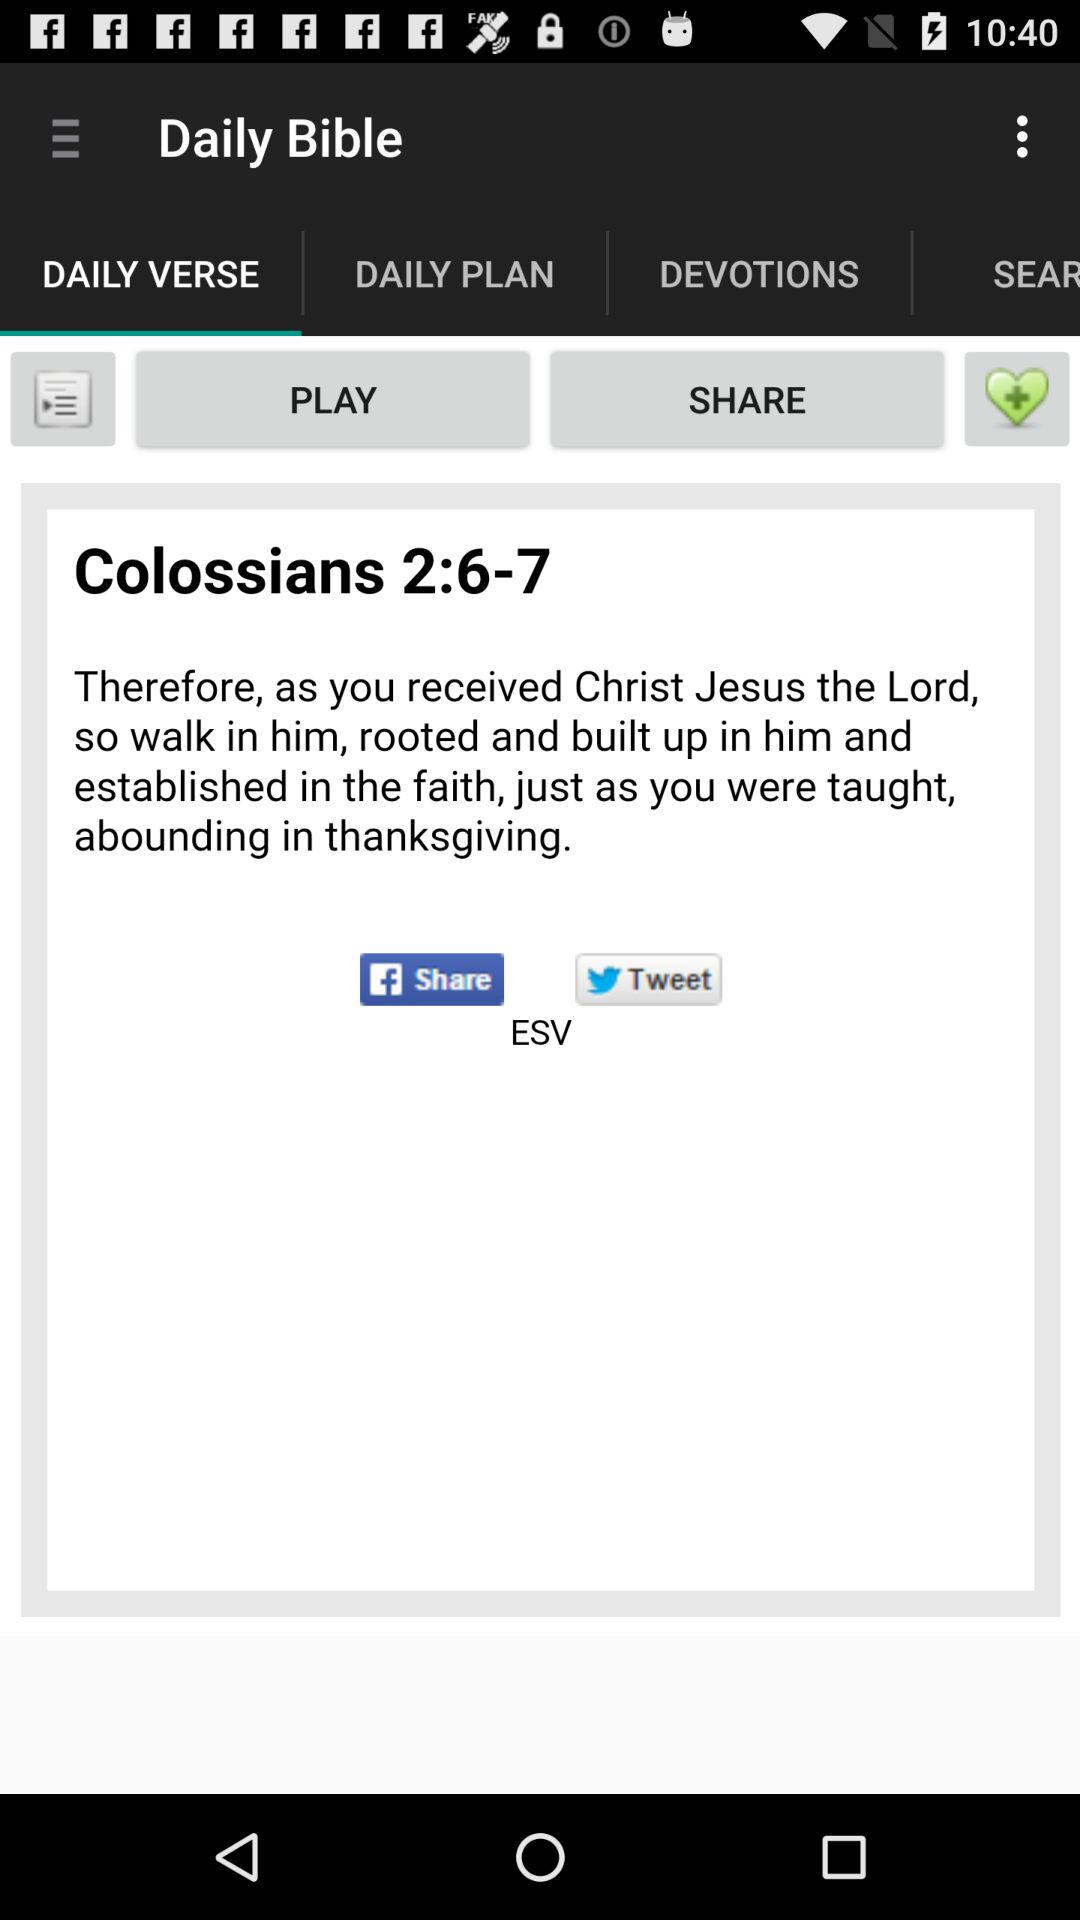Which tab is selected? The selected tab is "DAILY VERSE". 